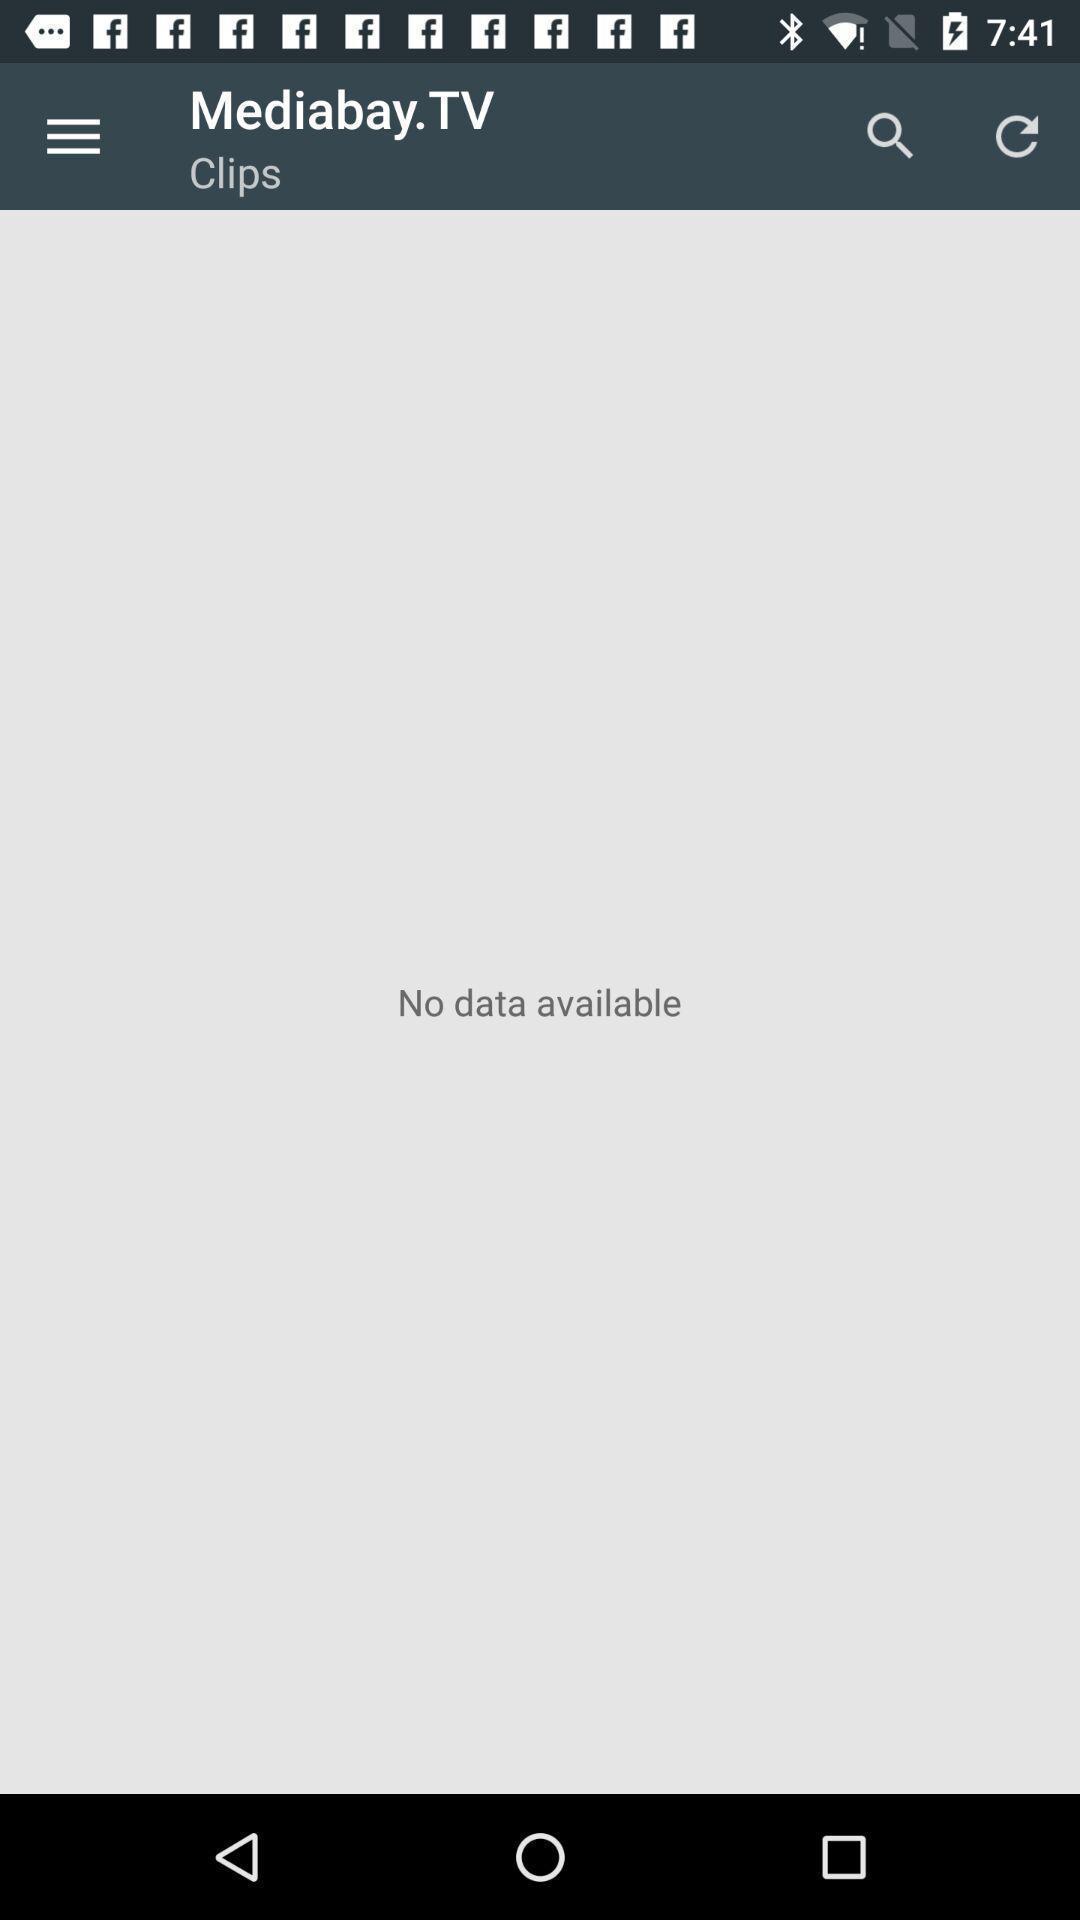Describe the visual elements of this screenshot. Page showing no data available. 